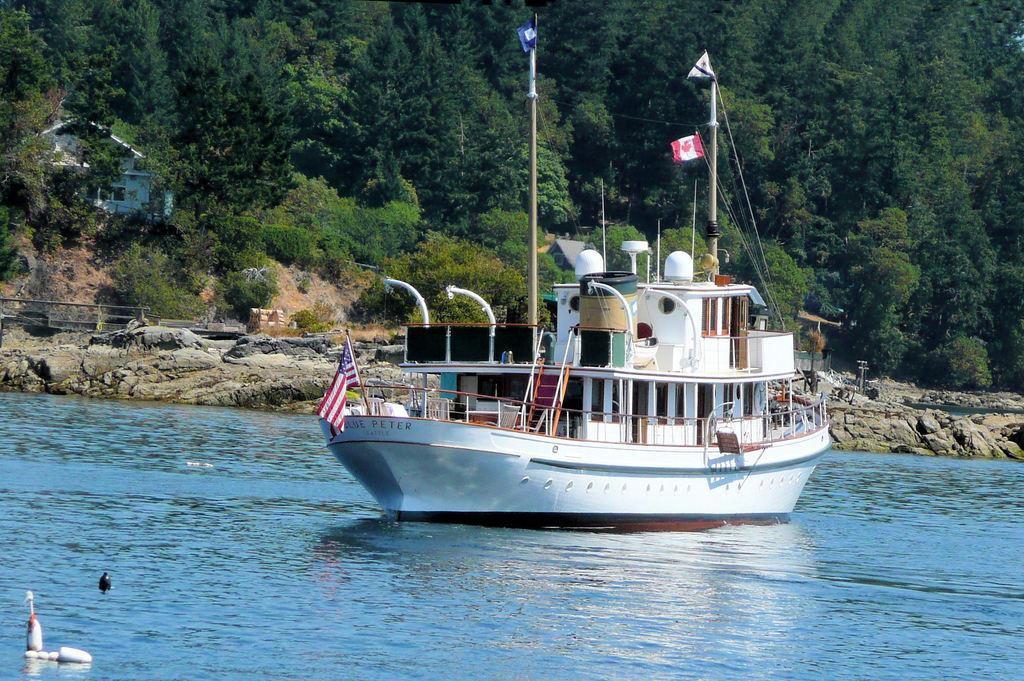<image>
Describe the image concisely. A white boat is going down a river and it says Blue Peter on the front. 